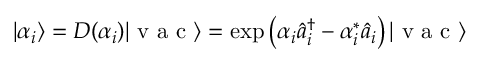Convert formula to latex. <formula><loc_0><loc_0><loc_500><loc_500>| \alpha _ { i } \rangle = D ( \alpha _ { i } ) | v a c \rangle = \exp \left ( \alpha _ { i } \hat { a } _ { i } ^ { \dagger } - \alpha _ { i } ^ { * } \hat { a } _ { i } \right ) | v a c \rangle</formula> 